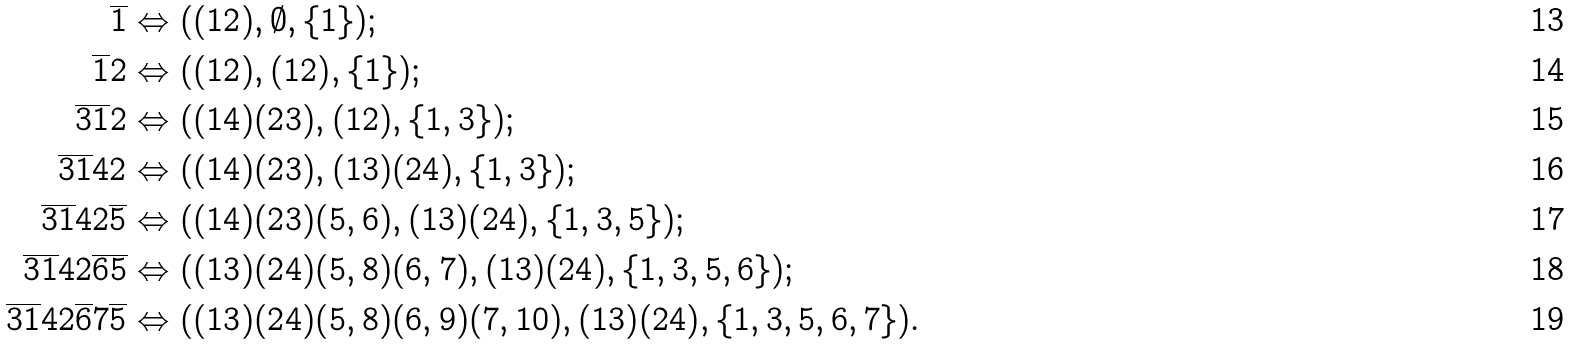Convert formula to latex. <formula><loc_0><loc_0><loc_500><loc_500>\overline { 1 } & \Leftrightarrow ( ( 1 2 ) , \emptyset , \{ 1 \} ) ; \\ \overline { 1 } 2 & \Leftrightarrow ( ( 1 2 ) , ( 1 2 ) , \{ 1 \} ) ; \\ \overline { 3 } \overline { 1 } 2 & \Leftrightarrow ( ( 1 4 ) ( 2 3 ) , ( 1 2 ) , \{ 1 , 3 \} ) ; \\ \overline { 3 } \overline { 1 } 4 2 & \Leftrightarrow ( ( 1 4 ) ( 2 3 ) , ( 1 3 ) ( 2 4 ) , \{ 1 , 3 \} ) ; \\ \overline { 3 } \overline { 1 } 4 2 \overline { 5 } & \Leftrightarrow ( ( 1 4 ) ( 2 3 ) ( 5 , 6 ) , ( 1 3 ) ( 2 4 ) , \{ 1 , 3 , 5 \} ) ; \\ \overline { 3 } \overline { 1 } 4 2 \overline { 6 } \overline { 5 } & \Leftrightarrow ( ( 1 3 ) ( 2 4 ) ( 5 , 8 ) ( 6 , 7 ) , ( 1 3 ) ( 2 4 ) , \{ 1 , 3 , 5 , 6 \} ) ; \\ \overline { 3 } \overline { 1 } 4 2 \overline { 6 } 7 \overline { 5 } & \Leftrightarrow ( ( 1 3 ) ( 2 4 ) ( 5 , 8 ) ( 6 , 9 ) ( 7 , 1 0 ) , ( 1 3 ) ( 2 4 ) , \{ 1 , 3 , 5 , 6 , 7 \} ) .</formula> 